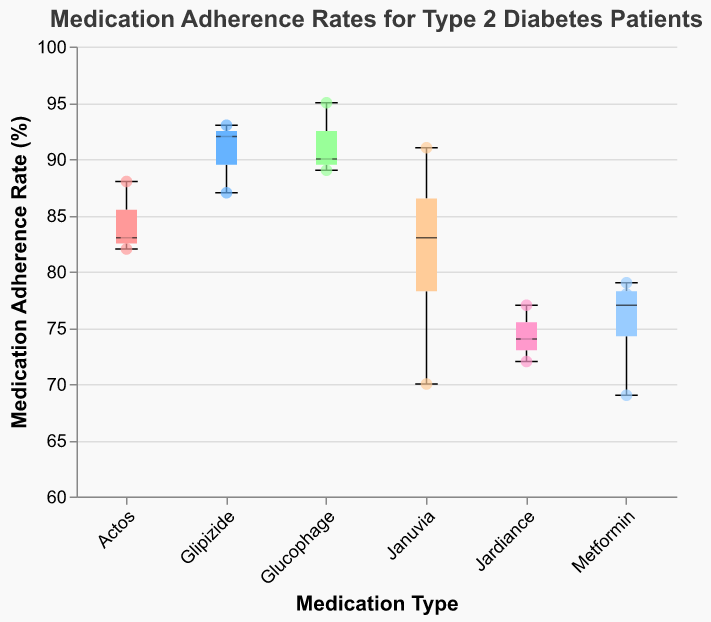What is the title of the figure? The title is typically located at the top of the figure and provides a summary of what the chart is about.
Answer: Medication Adherence Rates for Type 2 Diabetes Patients Which medication type has the lowest median adherence rate? The median is represented by a line within the box in the box plot for each medication type. By comparing these lines, we can identify the lowest one.
Answer: Metformin How many patients are taking each type of medication? Count the number of scatter points above each medication type along the x-axis.
Answer: Januvia: 4, Metformin: 4, Glipizide: 3, Jardiance: 3, Actos: 3, Glucophage: 3 Which medication type has the highest maximum adherence rate? The maximum adherence rate for each medication type is shown by the upper whisker of the box plot. Identify the highest whisker.
Answer: Glucophage What is the interquartile range (IQR) of adherence rates for Actos? The IQR is the difference between the upper (75th percentile) and lower (25th percentile) quartiles. Locate these points within the box plot for Actos.
Answer: 6 (88 - 82) Which medication type shows the most variability in adherence rates? Variability can be assessed by the length of the whiskers and the spread of points. The longer the whiskers and the spread, the higher the variability.
Answer: Metformin What is the median adherence rate for patients on Glipizide? The median is shown as the line inside the box in the box plot for Glipizide.
Answer: 92 Are there any outliers in the adherence rates for any medication type? Outliers would be individual points lying outside the whiskers of the box plot.
Answer: No How does the median adherence rate for Januvia compare to that of Jardiance? Compare the position of the median lines inside the boxes for Januvia and Jardiance.
Answer: Januvia is higher What range does the adherence rate for Januvia span? The range is from the minimum to the maximum adherence rate, displayed by the whiskers of the box plot for Januvia.
Answer: 70 to 91 